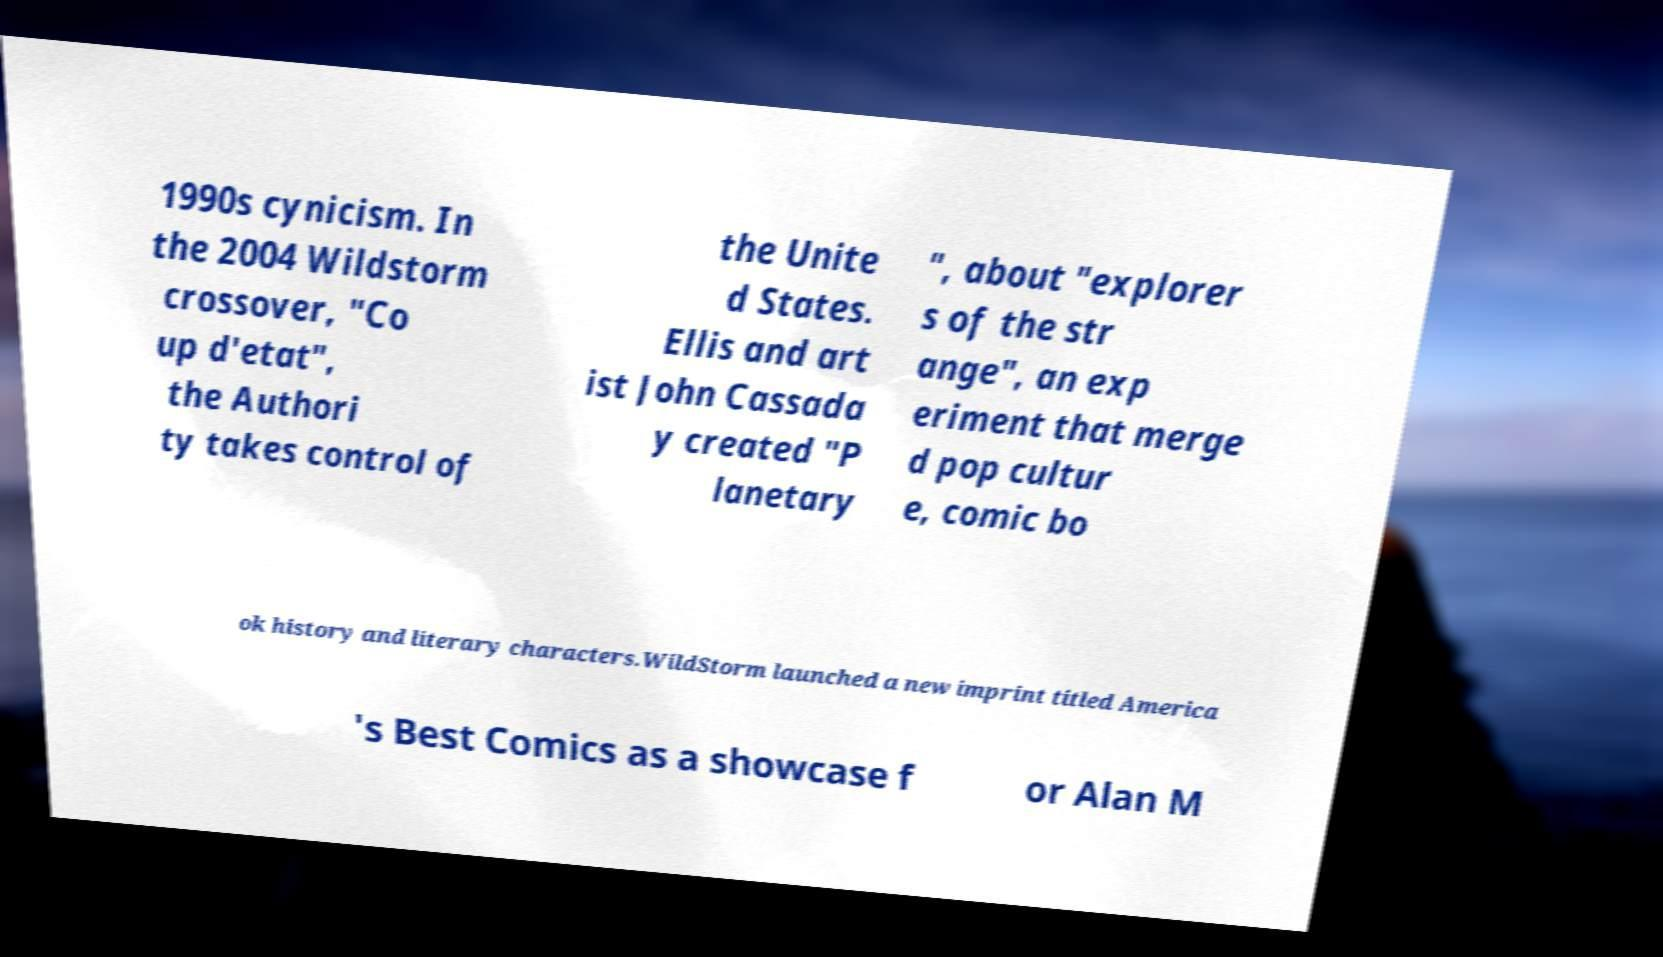What messages or text are displayed in this image? I need them in a readable, typed format. 1990s cynicism. In the 2004 Wildstorm crossover, "Co up d'etat", the Authori ty takes control of the Unite d States. Ellis and art ist John Cassada y created "P lanetary ", about "explorer s of the str ange", an exp eriment that merge d pop cultur e, comic bo ok history and literary characters.WildStorm launched a new imprint titled America 's Best Comics as a showcase f or Alan M 